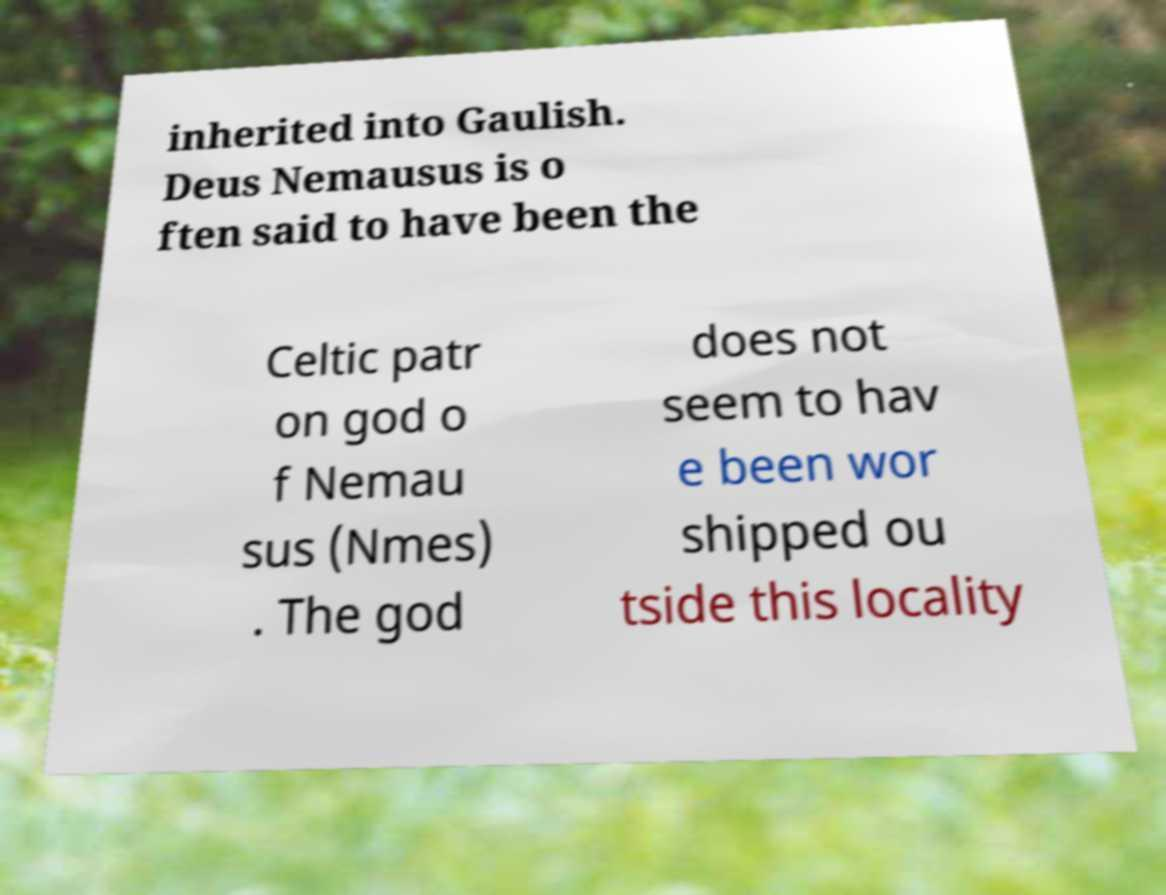I need the written content from this picture converted into text. Can you do that? inherited into Gaulish. Deus Nemausus is o ften said to have been the Celtic patr on god o f Nemau sus (Nmes) . The god does not seem to hav e been wor shipped ou tside this locality 